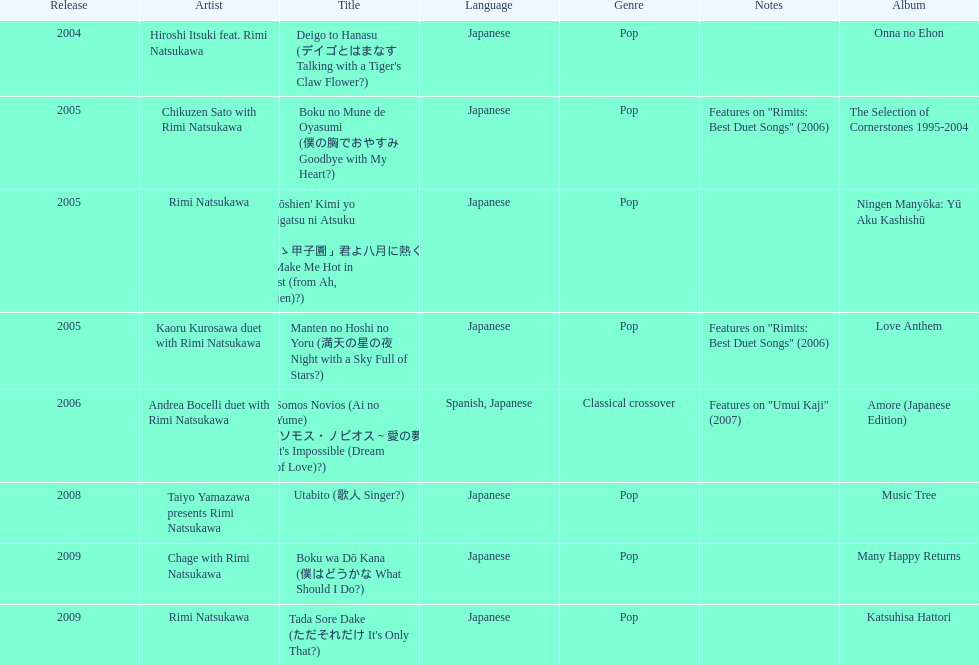How many titles have only one artist? 2. 